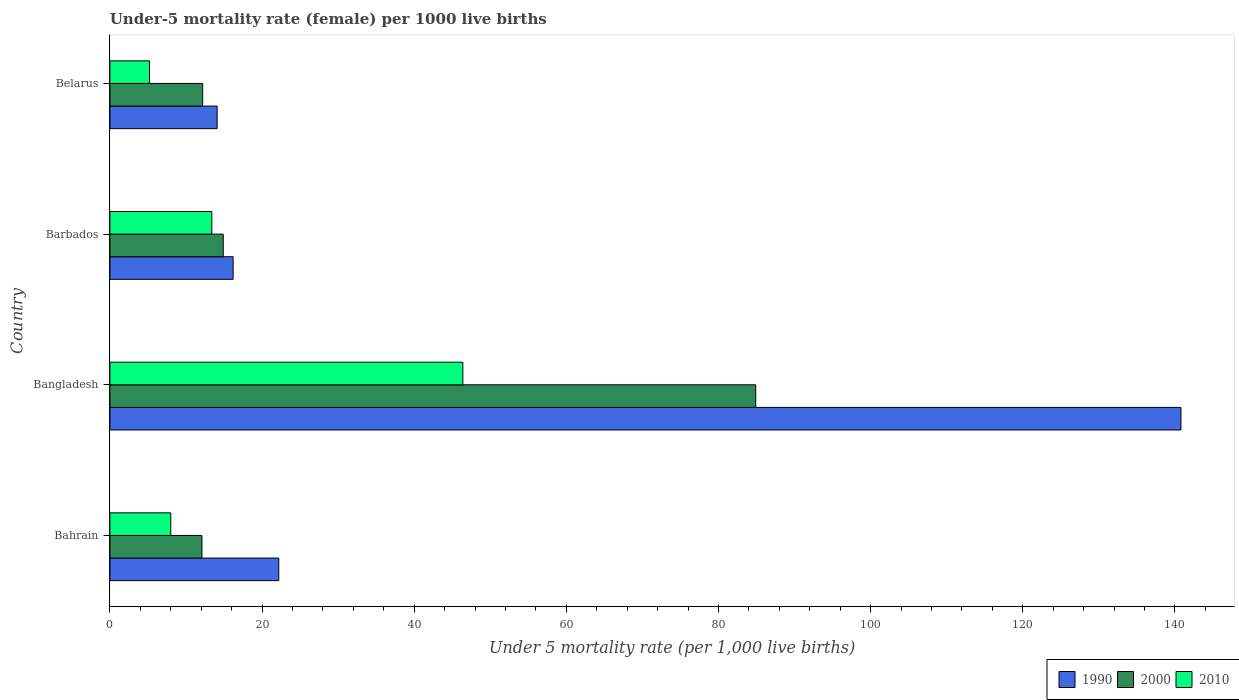Are the number of bars on each tick of the Y-axis equal?
Offer a terse response. Yes. How many bars are there on the 4th tick from the top?
Ensure brevity in your answer.  3. What is the label of the 4th group of bars from the top?
Give a very brief answer. Bahrain. What is the under-five mortality rate in 1990 in Bangladesh?
Offer a very short reply. 140.8. Across all countries, what is the maximum under-five mortality rate in 2010?
Your response must be concise. 46.4. In which country was the under-five mortality rate in 1990 maximum?
Provide a short and direct response. Bangladesh. In which country was the under-five mortality rate in 1990 minimum?
Make the answer very short. Belarus. What is the difference between the under-five mortality rate in 1990 in Bahrain and that in Bangladesh?
Your response must be concise. -118.6. What is the difference between the under-five mortality rate in 1990 in Bangladesh and the under-five mortality rate in 2000 in Barbados?
Keep it short and to the point. 125.9. What is the average under-five mortality rate in 1990 per country?
Your response must be concise. 48.32. In how many countries, is the under-five mortality rate in 2010 greater than 76 ?
Provide a short and direct response. 0. What is the ratio of the under-five mortality rate in 1990 in Bangladesh to that in Barbados?
Your answer should be very brief. 8.69. What is the difference between the highest and the lowest under-five mortality rate in 2000?
Make the answer very short. 72.8. In how many countries, is the under-five mortality rate in 2010 greater than the average under-five mortality rate in 2010 taken over all countries?
Your answer should be compact. 1. What does the 1st bar from the top in Belarus represents?
Make the answer very short. 2010. What does the 3rd bar from the bottom in Bahrain represents?
Offer a very short reply. 2010. Are all the bars in the graph horizontal?
Keep it short and to the point. Yes. How many countries are there in the graph?
Offer a very short reply. 4. Does the graph contain grids?
Make the answer very short. No. Where does the legend appear in the graph?
Ensure brevity in your answer.  Bottom right. How are the legend labels stacked?
Provide a short and direct response. Horizontal. What is the title of the graph?
Give a very brief answer. Under-5 mortality rate (female) per 1000 live births. Does "1971" appear as one of the legend labels in the graph?
Your answer should be very brief. No. What is the label or title of the X-axis?
Keep it short and to the point. Under 5 mortality rate (per 1,0 live births). What is the Under 5 mortality rate (per 1,000 live births) of 1990 in Bahrain?
Your response must be concise. 22.2. What is the Under 5 mortality rate (per 1,000 live births) in 2000 in Bahrain?
Your answer should be compact. 12.1. What is the Under 5 mortality rate (per 1,000 live births) in 2010 in Bahrain?
Provide a short and direct response. 8. What is the Under 5 mortality rate (per 1,000 live births) in 1990 in Bangladesh?
Offer a very short reply. 140.8. What is the Under 5 mortality rate (per 1,000 live births) in 2000 in Bangladesh?
Your response must be concise. 84.9. What is the Under 5 mortality rate (per 1,000 live births) in 2010 in Bangladesh?
Your answer should be very brief. 46.4. What is the Under 5 mortality rate (per 1,000 live births) of 1990 in Barbados?
Provide a succinct answer. 16.2. What is the Under 5 mortality rate (per 1,000 live births) of 2000 in Barbados?
Your answer should be compact. 14.9. What is the Under 5 mortality rate (per 1,000 live births) of 1990 in Belarus?
Provide a short and direct response. 14.1. Across all countries, what is the maximum Under 5 mortality rate (per 1,000 live births) of 1990?
Provide a succinct answer. 140.8. Across all countries, what is the maximum Under 5 mortality rate (per 1,000 live births) in 2000?
Your response must be concise. 84.9. Across all countries, what is the maximum Under 5 mortality rate (per 1,000 live births) in 2010?
Your answer should be very brief. 46.4. Across all countries, what is the minimum Under 5 mortality rate (per 1,000 live births) of 1990?
Your answer should be very brief. 14.1. Across all countries, what is the minimum Under 5 mortality rate (per 1,000 live births) in 2000?
Your response must be concise. 12.1. What is the total Under 5 mortality rate (per 1,000 live births) in 1990 in the graph?
Keep it short and to the point. 193.3. What is the total Under 5 mortality rate (per 1,000 live births) of 2000 in the graph?
Keep it short and to the point. 124.1. What is the difference between the Under 5 mortality rate (per 1,000 live births) of 1990 in Bahrain and that in Bangladesh?
Keep it short and to the point. -118.6. What is the difference between the Under 5 mortality rate (per 1,000 live births) in 2000 in Bahrain and that in Bangladesh?
Provide a short and direct response. -72.8. What is the difference between the Under 5 mortality rate (per 1,000 live births) of 2010 in Bahrain and that in Bangladesh?
Your response must be concise. -38.4. What is the difference between the Under 5 mortality rate (per 1,000 live births) in 1990 in Bahrain and that in Barbados?
Your answer should be compact. 6. What is the difference between the Under 5 mortality rate (per 1,000 live births) in 1990 in Bangladesh and that in Barbados?
Offer a very short reply. 124.6. What is the difference between the Under 5 mortality rate (per 1,000 live births) of 2000 in Bangladesh and that in Barbados?
Ensure brevity in your answer.  70. What is the difference between the Under 5 mortality rate (per 1,000 live births) in 1990 in Bangladesh and that in Belarus?
Your answer should be very brief. 126.7. What is the difference between the Under 5 mortality rate (per 1,000 live births) in 2000 in Bangladesh and that in Belarus?
Provide a succinct answer. 72.7. What is the difference between the Under 5 mortality rate (per 1,000 live births) of 2010 in Bangladesh and that in Belarus?
Provide a short and direct response. 41.2. What is the difference between the Under 5 mortality rate (per 1,000 live births) in 1990 in Barbados and that in Belarus?
Provide a succinct answer. 2.1. What is the difference between the Under 5 mortality rate (per 1,000 live births) in 2010 in Barbados and that in Belarus?
Your answer should be very brief. 8.2. What is the difference between the Under 5 mortality rate (per 1,000 live births) of 1990 in Bahrain and the Under 5 mortality rate (per 1,000 live births) of 2000 in Bangladesh?
Provide a short and direct response. -62.7. What is the difference between the Under 5 mortality rate (per 1,000 live births) of 1990 in Bahrain and the Under 5 mortality rate (per 1,000 live births) of 2010 in Bangladesh?
Your answer should be compact. -24.2. What is the difference between the Under 5 mortality rate (per 1,000 live births) of 2000 in Bahrain and the Under 5 mortality rate (per 1,000 live births) of 2010 in Bangladesh?
Provide a short and direct response. -34.3. What is the difference between the Under 5 mortality rate (per 1,000 live births) in 1990 in Bahrain and the Under 5 mortality rate (per 1,000 live births) in 2010 in Barbados?
Provide a succinct answer. 8.8. What is the difference between the Under 5 mortality rate (per 1,000 live births) in 2000 in Bahrain and the Under 5 mortality rate (per 1,000 live births) in 2010 in Belarus?
Provide a short and direct response. 6.9. What is the difference between the Under 5 mortality rate (per 1,000 live births) in 1990 in Bangladesh and the Under 5 mortality rate (per 1,000 live births) in 2000 in Barbados?
Give a very brief answer. 125.9. What is the difference between the Under 5 mortality rate (per 1,000 live births) in 1990 in Bangladesh and the Under 5 mortality rate (per 1,000 live births) in 2010 in Barbados?
Offer a terse response. 127.4. What is the difference between the Under 5 mortality rate (per 1,000 live births) in 2000 in Bangladesh and the Under 5 mortality rate (per 1,000 live births) in 2010 in Barbados?
Ensure brevity in your answer.  71.5. What is the difference between the Under 5 mortality rate (per 1,000 live births) in 1990 in Bangladesh and the Under 5 mortality rate (per 1,000 live births) in 2000 in Belarus?
Your answer should be very brief. 128.6. What is the difference between the Under 5 mortality rate (per 1,000 live births) in 1990 in Bangladesh and the Under 5 mortality rate (per 1,000 live births) in 2010 in Belarus?
Ensure brevity in your answer.  135.6. What is the difference between the Under 5 mortality rate (per 1,000 live births) of 2000 in Bangladesh and the Under 5 mortality rate (per 1,000 live births) of 2010 in Belarus?
Your response must be concise. 79.7. What is the difference between the Under 5 mortality rate (per 1,000 live births) in 1990 in Barbados and the Under 5 mortality rate (per 1,000 live births) in 2000 in Belarus?
Offer a very short reply. 4. What is the difference between the Under 5 mortality rate (per 1,000 live births) of 1990 in Barbados and the Under 5 mortality rate (per 1,000 live births) of 2010 in Belarus?
Offer a very short reply. 11. What is the average Under 5 mortality rate (per 1,000 live births) of 1990 per country?
Your response must be concise. 48.33. What is the average Under 5 mortality rate (per 1,000 live births) of 2000 per country?
Make the answer very short. 31.02. What is the average Under 5 mortality rate (per 1,000 live births) of 2010 per country?
Offer a very short reply. 18.25. What is the difference between the Under 5 mortality rate (per 1,000 live births) in 1990 and Under 5 mortality rate (per 1,000 live births) in 2000 in Bangladesh?
Ensure brevity in your answer.  55.9. What is the difference between the Under 5 mortality rate (per 1,000 live births) in 1990 and Under 5 mortality rate (per 1,000 live births) in 2010 in Bangladesh?
Offer a terse response. 94.4. What is the difference between the Under 5 mortality rate (per 1,000 live births) of 2000 and Under 5 mortality rate (per 1,000 live births) of 2010 in Bangladesh?
Your answer should be very brief. 38.5. What is the difference between the Under 5 mortality rate (per 1,000 live births) in 1990 and Under 5 mortality rate (per 1,000 live births) in 2000 in Barbados?
Offer a very short reply. 1.3. What is the difference between the Under 5 mortality rate (per 1,000 live births) in 1990 and Under 5 mortality rate (per 1,000 live births) in 2000 in Belarus?
Offer a terse response. 1.9. What is the difference between the Under 5 mortality rate (per 1,000 live births) of 1990 and Under 5 mortality rate (per 1,000 live births) of 2010 in Belarus?
Give a very brief answer. 8.9. What is the ratio of the Under 5 mortality rate (per 1,000 live births) in 1990 in Bahrain to that in Bangladesh?
Keep it short and to the point. 0.16. What is the ratio of the Under 5 mortality rate (per 1,000 live births) in 2000 in Bahrain to that in Bangladesh?
Your answer should be very brief. 0.14. What is the ratio of the Under 5 mortality rate (per 1,000 live births) in 2010 in Bahrain to that in Bangladesh?
Offer a very short reply. 0.17. What is the ratio of the Under 5 mortality rate (per 1,000 live births) in 1990 in Bahrain to that in Barbados?
Provide a short and direct response. 1.37. What is the ratio of the Under 5 mortality rate (per 1,000 live births) in 2000 in Bahrain to that in Barbados?
Your response must be concise. 0.81. What is the ratio of the Under 5 mortality rate (per 1,000 live births) of 2010 in Bahrain to that in Barbados?
Offer a terse response. 0.6. What is the ratio of the Under 5 mortality rate (per 1,000 live births) in 1990 in Bahrain to that in Belarus?
Make the answer very short. 1.57. What is the ratio of the Under 5 mortality rate (per 1,000 live births) of 2010 in Bahrain to that in Belarus?
Keep it short and to the point. 1.54. What is the ratio of the Under 5 mortality rate (per 1,000 live births) of 1990 in Bangladesh to that in Barbados?
Keep it short and to the point. 8.69. What is the ratio of the Under 5 mortality rate (per 1,000 live births) in 2000 in Bangladesh to that in Barbados?
Your response must be concise. 5.7. What is the ratio of the Under 5 mortality rate (per 1,000 live births) of 2010 in Bangladesh to that in Barbados?
Your response must be concise. 3.46. What is the ratio of the Under 5 mortality rate (per 1,000 live births) of 1990 in Bangladesh to that in Belarus?
Provide a short and direct response. 9.99. What is the ratio of the Under 5 mortality rate (per 1,000 live births) of 2000 in Bangladesh to that in Belarus?
Provide a short and direct response. 6.96. What is the ratio of the Under 5 mortality rate (per 1,000 live births) in 2010 in Bangladesh to that in Belarus?
Provide a short and direct response. 8.92. What is the ratio of the Under 5 mortality rate (per 1,000 live births) of 1990 in Barbados to that in Belarus?
Provide a succinct answer. 1.15. What is the ratio of the Under 5 mortality rate (per 1,000 live births) in 2000 in Barbados to that in Belarus?
Your answer should be very brief. 1.22. What is the ratio of the Under 5 mortality rate (per 1,000 live births) of 2010 in Barbados to that in Belarus?
Make the answer very short. 2.58. What is the difference between the highest and the second highest Under 5 mortality rate (per 1,000 live births) of 1990?
Your answer should be compact. 118.6. What is the difference between the highest and the second highest Under 5 mortality rate (per 1,000 live births) of 2000?
Your answer should be compact. 70. What is the difference between the highest and the lowest Under 5 mortality rate (per 1,000 live births) in 1990?
Keep it short and to the point. 126.7. What is the difference between the highest and the lowest Under 5 mortality rate (per 1,000 live births) in 2000?
Give a very brief answer. 72.8. What is the difference between the highest and the lowest Under 5 mortality rate (per 1,000 live births) of 2010?
Make the answer very short. 41.2. 